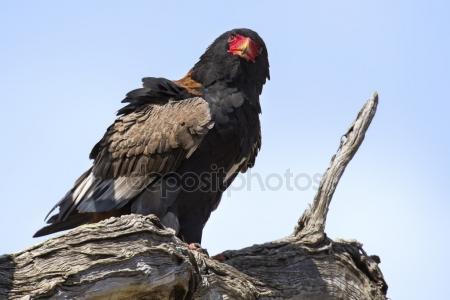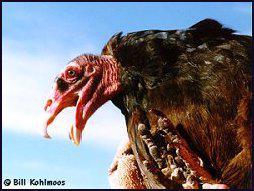The first image is the image on the left, the second image is the image on the right. Considering the images on both sides, is "The left image contains one vulture perched on a leafless branch, with its wings tucked." valid? Answer yes or no. Yes. The first image is the image on the left, the second image is the image on the right. For the images shown, is this caption "The left and right image contains a total of two vultures facing different directions." true? Answer yes or no. Yes. 